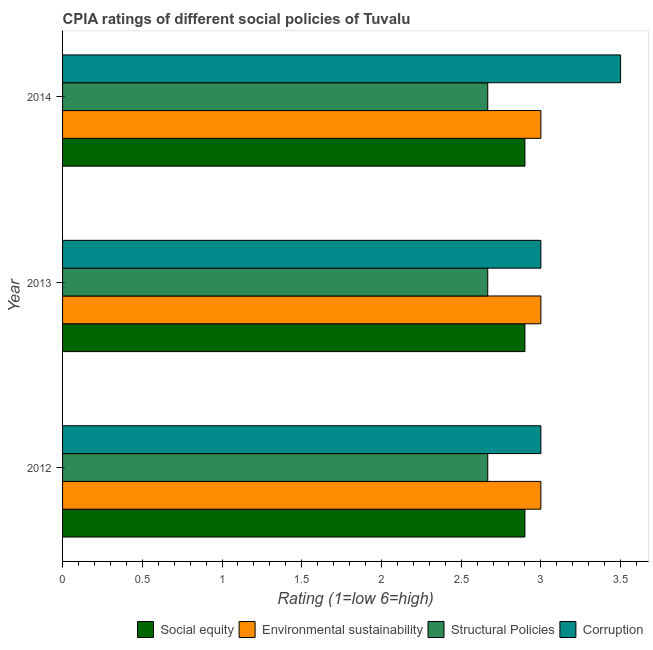How many groups of bars are there?
Keep it short and to the point. 3. Are the number of bars on each tick of the Y-axis equal?
Your answer should be compact. Yes. How many bars are there on the 3rd tick from the top?
Provide a short and direct response. 4. How many bars are there on the 2nd tick from the bottom?
Keep it short and to the point. 4. What is the label of the 2nd group of bars from the top?
Keep it short and to the point. 2013. What is the cpia rating of environmental sustainability in 2013?
Give a very brief answer. 3. Across all years, what is the maximum cpia rating of corruption?
Provide a short and direct response. 3.5. Across all years, what is the minimum cpia rating of social equity?
Offer a terse response. 2.9. What is the total cpia rating of environmental sustainability in the graph?
Your answer should be compact. 9. What is the difference between the cpia rating of structural policies in 2013 and the cpia rating of social equity in 2012?
Offer a very short reply. -0.23. What is the average cpia rating of corruption per year?
Your answer should be compact. 3.17. In the year 2013, what is the difference between the cpia rating of environmental sustainability and cpia rating of structural policies?
Keep it short and to the point. 0.33. Is the cpia rating of structural policies in 2013 less than that in 2014?
Your response must be concise. Yes. Is the difference between the cpia rating of environmental sustainability in 2013 and 2014 greater than the difference between the cpia rating of social equity in 2013 and 2014?
Ensure brevity in your answer.  No. What is the difference between the highest and the second highest cpia rating of environmental sustainability?
Your answer should be very brief. 0. What is the difference between the highest and the lowest cpia rating of social equity?
Provide a short and direct response. 0. Is the sum of the cpia rating of corruption in 2013 and 2014 greater than the maximum cpia rating of social equity across all years?
Provide a succinct answer. Yes. Is it the case that in every year, the sum of the cpia rating of structural policies and cpia rating of corruption is greater than the sum of cpia rating of environmental sustainability and cpia rating of social equity?
Give a very brief answer. No. What does the 1st bar from the top in 2012 represents?
Provide a succinct answer. Corruption. What does the 1st bar from the bottom in 2014 represents?
Offer a very short reply. Social equity. How many bars are there?
Keep it short and to the point. 12. Are all the bars in the graph horizontal?
Offer a very short reply. Yes. How many years are there in the graph?
Keep it short and to the point. 3. What is the difference between two consecutive major ticks on the X-axis?
Make the answer very short. 0.5. Are the values on the major ticks of X-axis written in scientific E-notation?
Your response must be concise. No. Does the graph contain grids?
Your answer should be compact. No. Where does the legend appear in the graph?
Give a very brief answer. Bottom right. How are the legend labels stacked?
Give a very brief answer. Horizontal. What is the title of the graph?
Your answer should be very brief. CPIA ratings of different social policies of Tuvalu. Does "Structural Policies" appear as one of the legend labels in the graph?
Ensure brevity in your answer.  Yes. What is the label or title of the Y-axis?
Offer a terse response. Year. What is the Rating (1=low 6=high) in Social equity in 2012?
Keep it short and to the point. 2.9. What is the Rating (1=low 6=high) of Structural Policies in 2012?
Your answer should be very brief. 2.67. What is the Rating (1=low 6=high) of Social equity in 2013?
Give a very brief answer. 2.9. What is the Rating (1=low 6=high) in Environmental sustainability in 2013?
Keep it short and to the point. 3. What is the Rating (1=low 6=high) in Structural Policies in 2013?
Keep it short and to the point. 2.67. What is the Rating (1=low 6=high) of Corruption in 2013?
Provide a short and direct response. 3. What is the Rating (1=low 6=high) in Social equity in 2014?
Give a very brief answer. 2.9. What is the Rating (1=low 6=high) of Environmental sustainability in 2014?
Offer a terse response. 3. What is the Rating (1=low 6=high) in Structural Policies in 2014?
Keep it short and to the point. 2.67. What is the Rating (1=low 6=high) of Corruption in 2014?
Give a very brief answer. 3.5. Across all years, what is the maximum Rating (1=low 6=high) of Environmental sustainability?
Make the answer very short. 3. Across all years, what is the maximum Rating (1=low 6=high) in Structural Policies?
Make the answer very short. 2.67. Across all years, what is the maximum Rating (1=low 6=high) of Corruption?
Make the answer very short. 3.5. Across all years, what is the minimum Rating (1=low 6=high) in Structural Policies?
Your answer should be compact. 2.67. What is the total Rating (1=low 6=high) of Environmental sustainability in the graph?
Keep it short and to the point. 9. What is the total Rating (1=low 6=high) in Structural Policies in the graph?
Offer a terse response. 8. What is the total Rating (1=low 6=high) in Corruption in the graph?
Offer a terse response. 9.5. What is the difference between the Rating (1=low 6=high) in Social equity in 2012 and that in 2013?
Keep it short and to the point. 0. What is the difference between the Rating (1=low 6=high) in Corruption in 2012 and that in 2013?
Your answer should be very brief. 0. What is the difference between the Rating (1=low 6=high) of Corruption in 2012 and that in 2014?
Provide a succinct answer. -0.5. What is the difference between the Rating (1=low 6=high) in Social equity in 2013 and that in 2014?
Provide a succinct answer. 0. What is the difference between the Rating (1=low 6=high) in Corruption in 2013 and that in 2014?
Provide a short and direct response. -0.5. What is the difference between the Rating (1=low 6=high) in Social equity in 2012 and the Rating (1=low 6=high) in Structural Policies in 2013?
Provide a succinct answer. 0.23. What is the difference between the Rating (1=low 6=high) of Social equity in 2012 and the Rating (1=low 6=high) of Corruption in 2013?
Offer a terse response. -0.1. What is the difference between the Rating (1=low 6=high) of Environmental sustainability in 2012 and the Rating (1=low 6=high) of Corruption in 2013?
Give a very brief answer. 0. What is the difference between the Rating (1=low 6=high) in Structural Policies in 2012 and the Rating (1=low 6=high) in Corruption in 2013?
Keep it short and to the point. -0.33. What is the difference between the Rating (1=low 6=high) in Social equity in 2012 and the Rating (1=low 6=high) in Structural Policies in 2014?
Offer a very short reply. 0.23. What is the difference between the Rating (1=low 6=high) of Environmental sustainability in 2012 and the Rating (1=low 6=high) of Structural Policies in 2014?
Your answer should be very brief. 0.33. What is the difference between the Rating (1=low 6=high) in Environmental sustainability in 2012 and the Rating (1=low 6=high) in Corruption in 2014?
Provide a succinct answer. -0.5. What is the difference between the Rating (1=low 6=high) in Structural Policies in 2012 and the Rating (1=low 6=high) in Corruption in 2014?
Make the answer very short. -0.83. What is the difference between the Rating (1=low 6=high) in Social equity in 2013 and the Rating (1=low 6=high) in Environmental sustainability in 2014?
Offer a very short reply. -0.1. What is the difference between the Rating (1=low 6=high) of Social equity in 2013 and the Rating (1=low 6=high) of Structural Policies in 2014?
Make the answer very short. 0.23. What is the difference between the Rating (1=low 6=high) of Social equity in 2013 and the Rating (1=low 6=high) of Corruption in 2014?
Keep it short and to the point. -0.6. What is the difference between the Rating (1=low 6=high) in Environmental sustainability in 2013 and the Rating (1=low 6=high) in Structural Policies in 2014?
Offer a terse response. 0.33. What is the difference between the Rating (1=low 6=high) in Environmental sustainability in 2013 and the Rating (1=low 6=high) in Corruption in 2014?
Give a very brief answer. -0.5. What is the average Rating (1=low 6=high) of Social equity per year?
Your answer should be very brief. 2.9. What is the average Rating (1=low 6=high) of Environmental sustainability per year?
Make the answer very short. 3. What is the average Rating (1=low 6=high) in Structural Policies per year?
Make the answer very short. 2.67. What is the average Rating (1=low 6=high) of Corruption per year?
Offer a very short reply. 3.17. In the year 2012, what is the difference between the Rating (1=low 6=high) of Social equity and Rating (1=low 6=high) of Environmental sustainability?
Your answer should be very brief. -0.1. In the year 2012, what is the difference between the Rating (1=low 6=high) of Social equity and Rating (1=low 6=high) of Structural Policies?
Your answer should be compact. 0.23. In the year 2012, what is the difference between the Rating (1=low 6=high) in Social equity and Rating (1=low 6=high) in Corruption?
Ensure brevity in your answer.  -0.1. In the year 2012, what is the difference between the Rating (1=low 6=high) of Environmental sustainability and Rating (1=low 6=high) of Structural Policies?
Your answer should be compact. 0.33. In the year 2013, what is the difference between the Rating (1=low 6=high) of Social equity and Rating (1=low 6=high) of Structural Policies?
Give a very brief answer. 0.23. In the year 2013, what is the difference between the Rating (1=low 6=high) in Social equity and Rating (1=low 6=high) in Corruption?
Provide a succinct answer. -0.1. In the year 2014, what is the difference between the Rating (1=low 6=high) in Social equity and Rating (1=low 6=high) in Environmental sustainability?
Provide a short and direct response. -0.1. In the year 2014, what is the difference between the Rating (1=low 6=high) of Social equity and Rating (1=low 6=high) of Structural Policies?
Offer a very short reply. 0.23. In the year 2014, what is the difference between the Rating (1=low 6=high) in Environmental sustainability and Rating (1=low 6=high) in Structural Policies?
Offer a terse response. 0.33. In the year 2014, what is the difference between the Rating (1=low 6=high) in Structural Policies and Rating (1=low 6=high) in Corruption?
Your response must be concise. -0.83. What is the ratio of the Rating (1=low 6=high) in Social equity in 2012 to that in 2013?
Your answer should be very brief. 1. What is the ratio of the Rating (1=low 6=high) of Structural Policies in 2012 to that in 2013?
Keep it short and to the point. 1. What is the ratio of the Rating (1=low 6=high) of Social equity in 2012 to that in 2014?
Your response must be concise. 1. What is the ratio of the Rating (1=low 6=high) in Environmental sustainability in 2012 to that in 2014?
Make the answer very short. 1. What is the ratio of the Rating (1=low 6=high) of Corruption in 2012 to that in 2014?
Provide a short and direct response. 0.86. What is the ratio of the Rating (1=low 6=high) of Environmental sustainability in 2013 to that in 2014?
Your answer should be very brief. 1. What is the difference between the highest and the lowest Rating (1=low 6=high) in Social equity?
Provide a succinct answer. 0. What is the difference between the highest and the lowest Rating (1=low 6=high) of Environmental sustainability?
Provide a short and direct response. 0. What is the difference between the highest and the lowest Rating (1=low 6=high) in Corruption?
Ensure brevity in your answer.  0.5. 